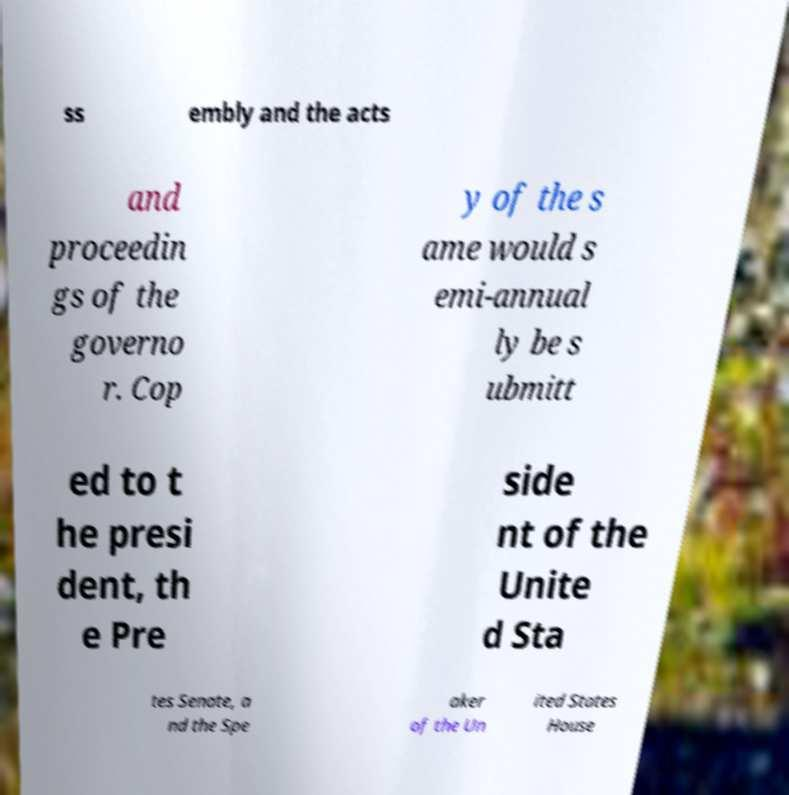There's text embedded in this image that I need extracted. Can you transcribe it verbatim? ss embly and the acts and proceedin gs of the governo r. Cop y of the s ame would s emi-annual ly be s ubmitt ed to t he presi dent, th e Pre side nt of the Unite d Sta tes Senate, a nd the Spe aker of the Un ited States House 